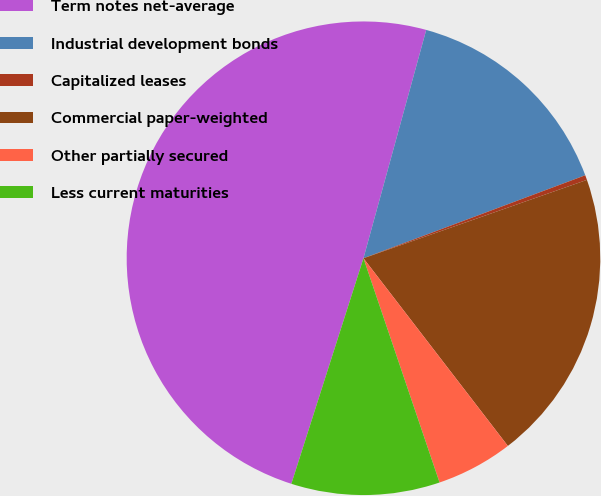Convert chart. <chart><loc_0><loc_0><loc_500><loc_500><pie_chart><fcel>Term notes net-average<fcel>Industrial development bonds<fcel>Capitalized leases<fcel>Commercial paper-weighted<fcel>Other partially secured<fcel>Less current maturities<nl><fcel>49.34%<fcel>15.03%<fcel>0.33%<fcel>19.93%<fcel>5.23%<fcel>10.13%<nl></chart> 